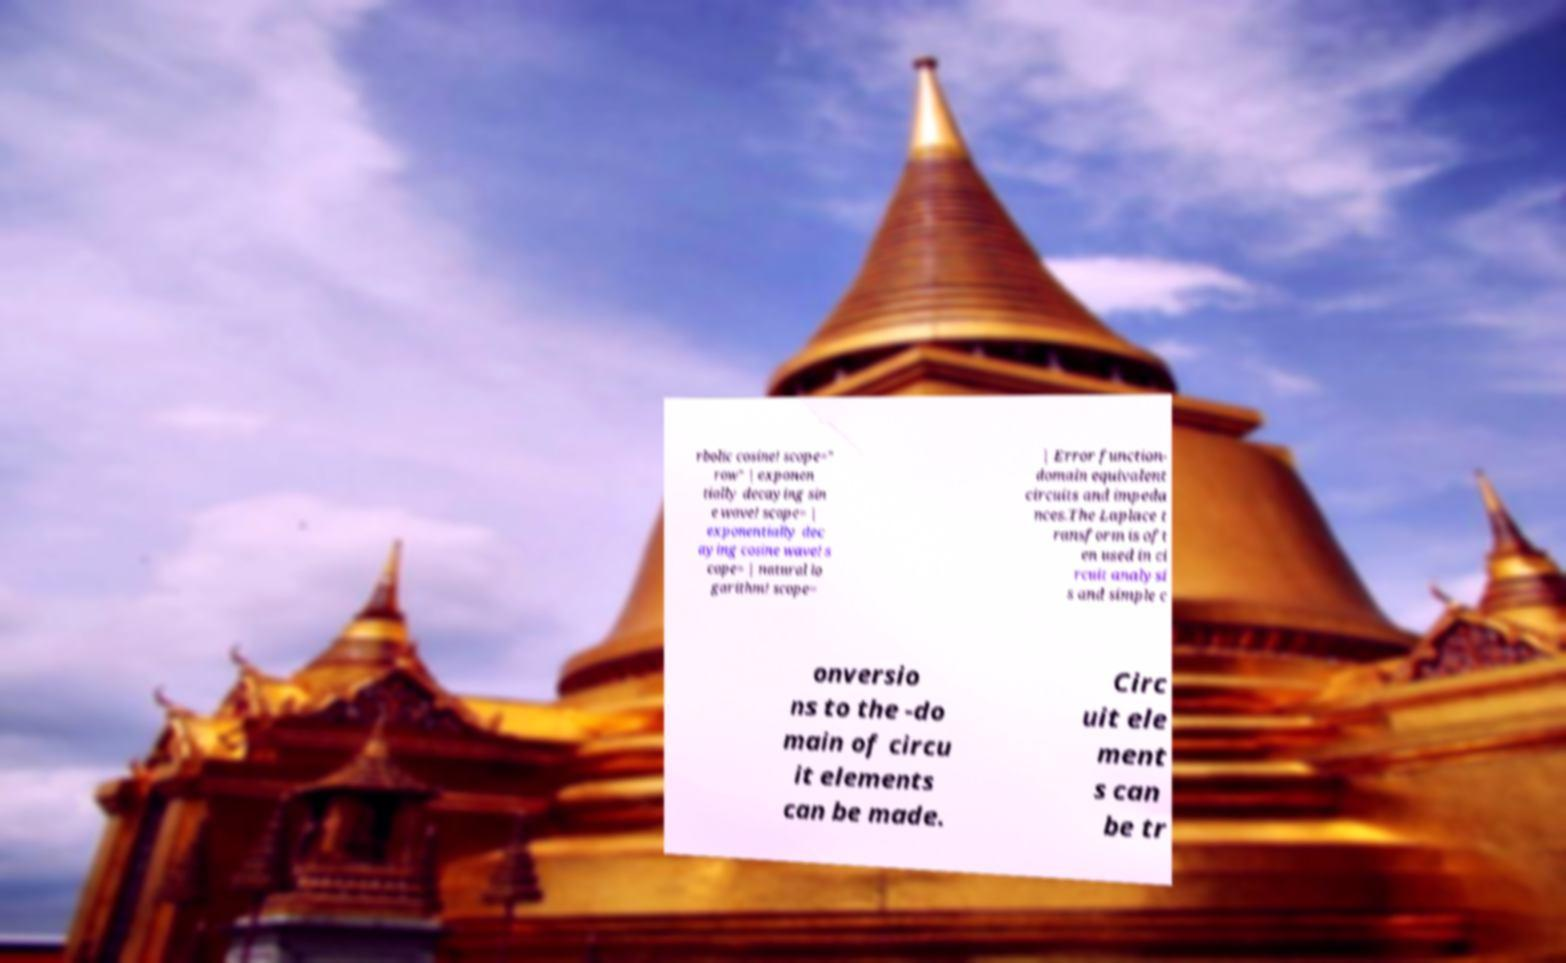Please identify and transcribe the text found in this image. rbolic cosine! scope=" row" | exponen tially decaying sin e wave! scope= | exponentially dec aying cosine wave! s cope= | natural lo garithm! scope= | Error function- domain equivalent circuits and impeda nces.The Laplace t ransform is oft en used in ci rcuit analysi s and simple c onversio ns to the -do main of circu it elements can be made. Circ uit ele ment s can be tr 